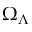Convert formula to latex. <formula><loc_0><loc_0><loc_500><loc_500>\Omega _ { \Lambda }</formula> 